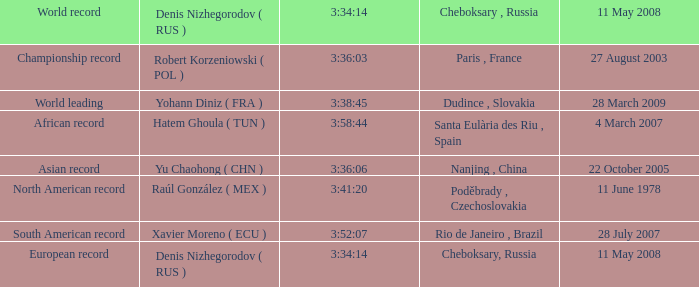When the north american record turns into the world record, who is denis nizhegorodov (rus)? Raúl González ( MEX ). 